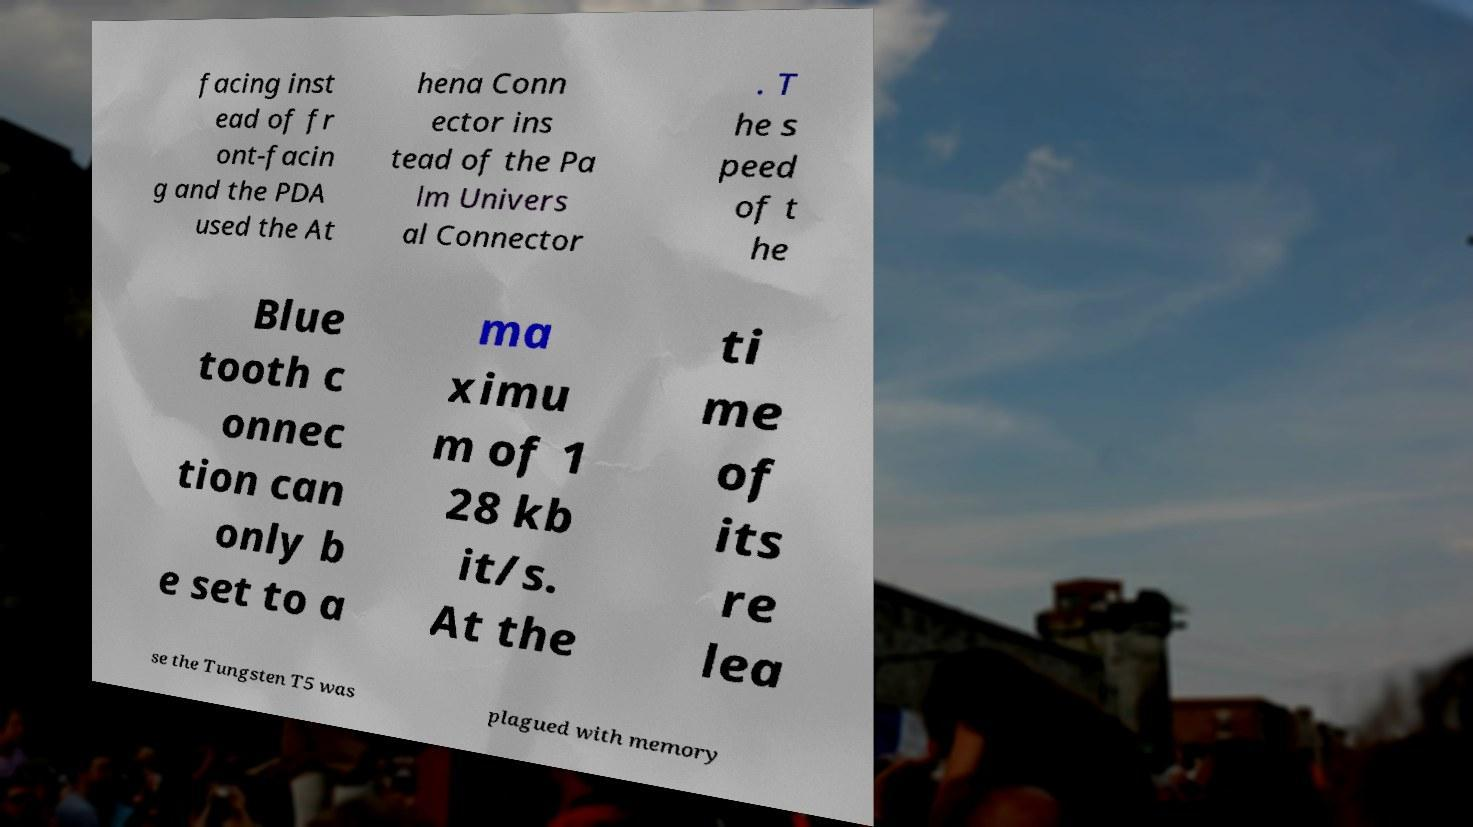Can you read and provide the text displayed in the image?This photo seems to have some interesting text. Can you extract and type it out for me? facing inst ead of fr ont-facin g and the PDA used the At hena Conn ector ins tead of the Pa lm Univers al Connector . T he s peed of t he Blue tooth c onnec tion can only b e set to a ma ximu m of 1 28 kb it/s. At the ti me of its re lea se the Tungsten T5 was plagued with memory 